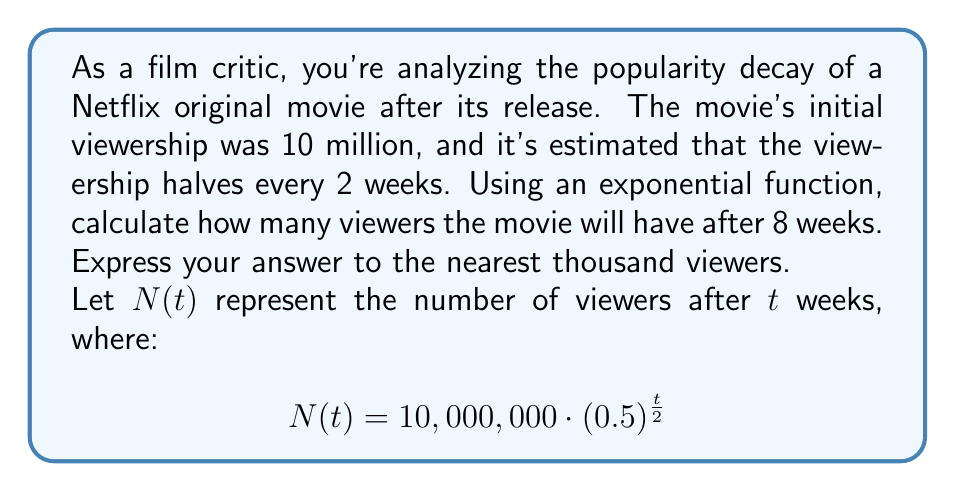Provide a solution to this math problem. To solve this problem, we'll use the given exponential function and follow these steps:

1) The function is given as:
   $$N(t) = 10,000,000 \cdot (0.5)^{\frac{t}{2}}$$

2) We need to find $N(8)$, as we're looking for the viewership after 8 weeks:
   $$N(8) = 10,000,000 \cdot (0.5)^{\frac{8}{2}}$$

3) Simplify the exponent:
   $$N(8) = 10,000,000 \cdot (0.5)^4$$

4) Calculate $(0.5)^4$:
   $$(0.5)^4 = 0.5 \cdot 0.5 \cdot 0.5 \cdot 0.5 = 0.0625$$

5) Multiply:
   $$N(8) = 10,000,000 \cdot 0.0625 = 625,000$$

6) The question asks for the answer to the nearest thousand, so our final answer is 625,000.
Answer: 625,000 viewers 